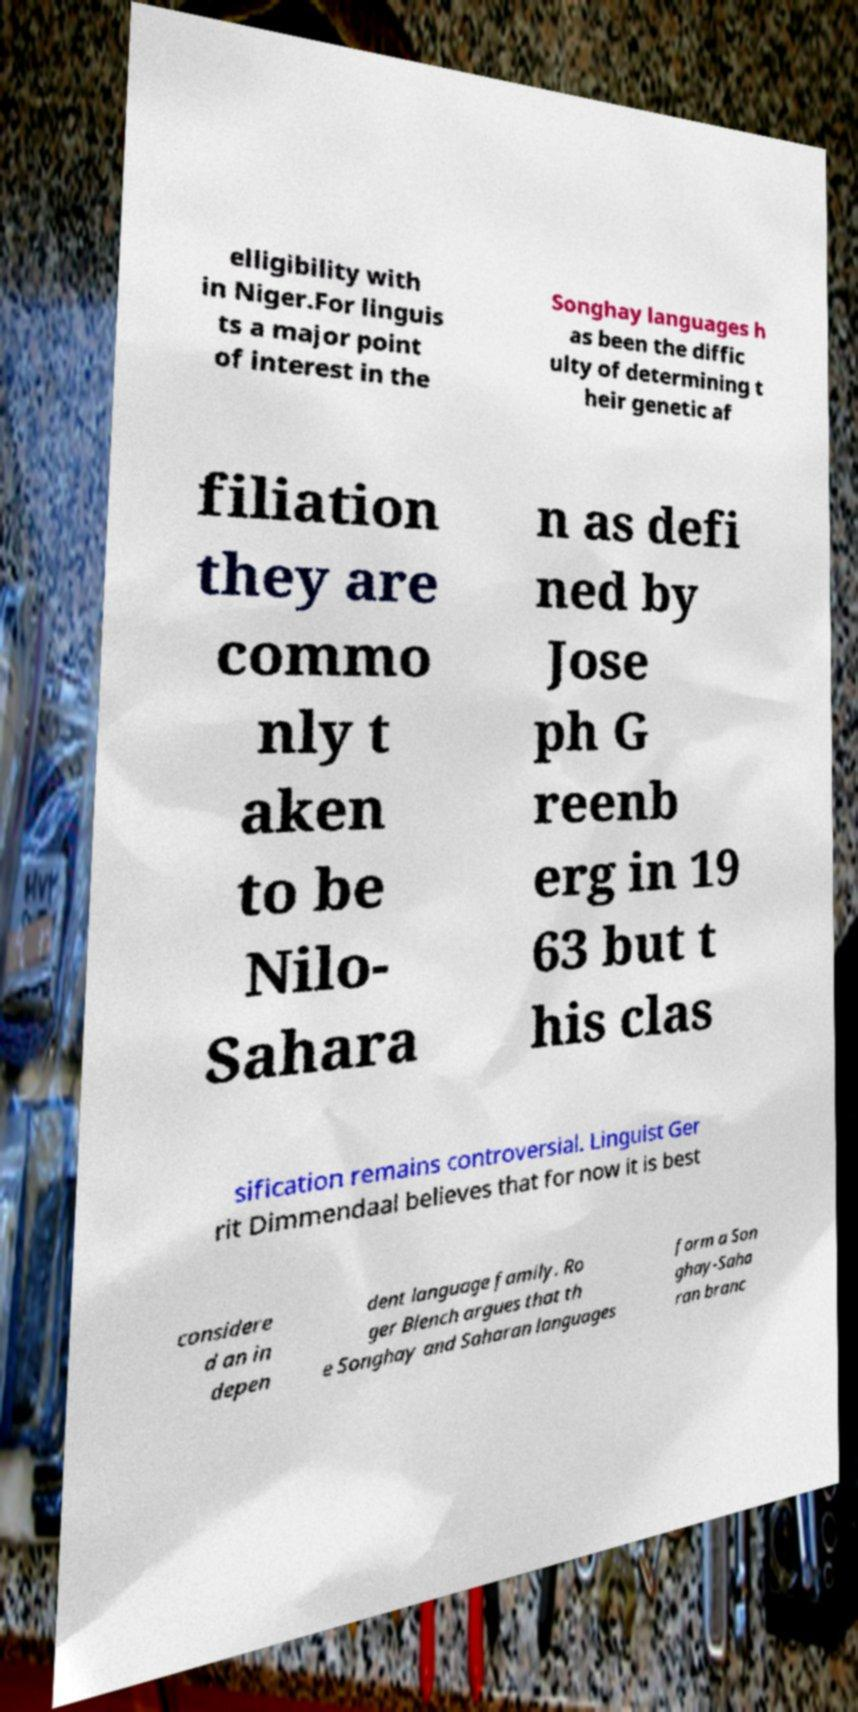Can you accurately transcribe the text from the provided image for me? elligibility with in Niger.For linguis ts a major point of interest in the Songhay languages h as been the diffic ulty of determining t heir genetic af filiation they are commo nly t aken to be Nilo- Sahara n as defi ned by Jose ph G reenb erg in 19 63 but t his clas sification remains controversial. Linguist Ger rit Dimmendaal believes that for now it is best considere d an in depen dent language family. Ro ger Blench argues that th e Songhay and Saharan languages form a Son ghay-Saha ran branc 